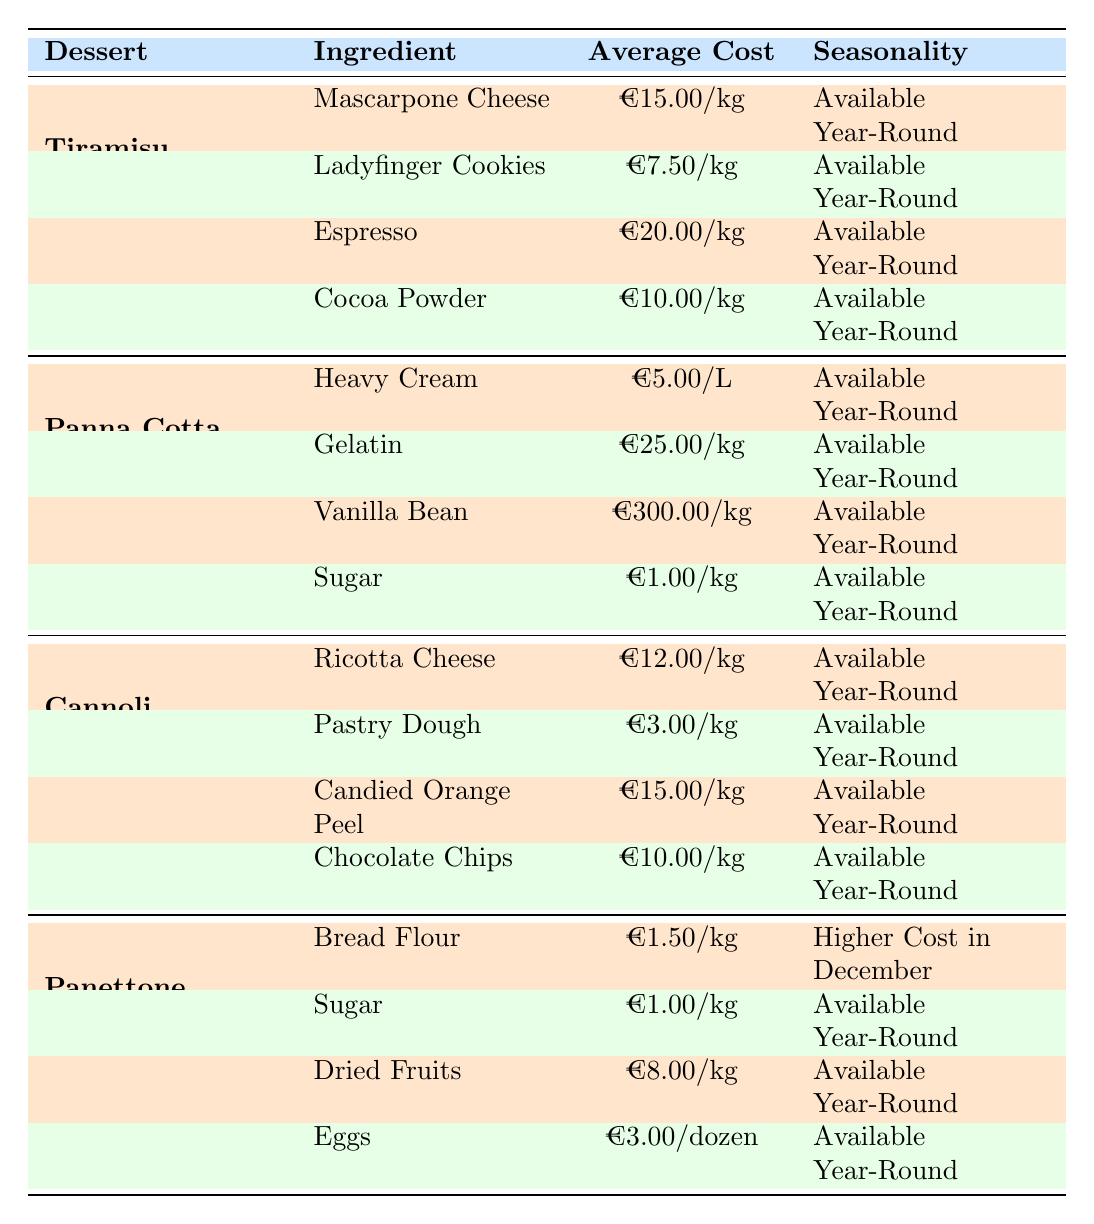What is the average cost of the ingredients for Tiramisu? The ingredients for Tiramisu are Mascarpone Cheese (€15.00/kg), Ladyfinger Cookies (€7.50/kg), Espresso (€20.00/kg), and Cocoa Powder (€10.00/kg). To find the average, sum these costs: 15 + 7.5 + 20 + 10 = 52.5. Divide by the number of ingredients (4): 52.5/4 = 13.125.
Answer: 13.13 Which ingredient for Panna Cotta is the most expensive? The ingredients are Heavy Cream (€5.00/L), Gelatin (€25.00/kg), Vanilla Bean (€300.00/kg), and Sugar (€1.00/kg). The highest price is for Vanilla Bean at €300.00/kg.
Answer: Vanilla Bean Is Sugar a common ingredient in all desserts listed? Sugar appears as an ingredient in both Panna Cotta and Panettone, but not in Tiramisu or Cannoli. Therefore, it is not common to all desserts.
Answer: No What is the total cost of ingredients for Cannoli? The ingredients for Cannoli are Ricotta Cheese (€12.00/kg), Pastry Dough (€3.00/kg), Candied Orange Peel (€15.00/kg), and Chocolate Chips (€10.00/kg). Summing these: 12 + 3 + 15 + 10 = 40.
Answer: 40 Which dessert has an ingredient that is more expensive than any in Tiramisu? In Tiramisu, the most expensive ingredient is Espresso at €20.00/kg. The Vanilla Bean in Panna Cotta costs €300.00/kg, which is higher than Espresso. The answer is Panna Cotta.
Answer: Panna Cotta What is the average cost of the ingredients for Panettone? The ingredients are Bread Flour (€1.50/kg), Sugar (€1.00/kg), Dried Fruits (€8.00/kg), and Eggs (€3.00/dozen). Calculating the average: (1.5 + 1 + 8 + 3) = 13.5. There are 4 ingredients; thus, the average cost is 13.5/4 = 3.375.
Answer: 3.38 Are all the ingredients for Cannoli available year-round? The ingredients for Cannoli are Ricotta Cheese, Pastry Dough, Candied Orange Peel, and Chocolate Chips, and they are all indicated as available year-round.
Answer: Yes What ingredient has the highest average cost per kg across all desserts? The costs are as follows: Mascarpone Cheese (€15.00/kg), Ladyfinger Cookies (€7.50/kg), Espresso (€20.00/kg), Cocoa Powder (€10.00/kg), Heavy Cream (€5.00/L), Gelatin (€25.00/kg), Vanilla Bean (€300.00/kg), Sugar (€1.00/kg), Ricotta Cheese (€12.00/kg), Pastry Dough (€3.00/kg), Candied Orange Peel (€15.00/kg), Chocolate Chips (€10.00/kg), Bread Flour (€1.50/kg), and Dried Fruits (€8.00/kg), Eggs (€3.00/dozen). The highest cost is Vanilla Bean at €300.00/kg.
Answer: Vanilla Bean 